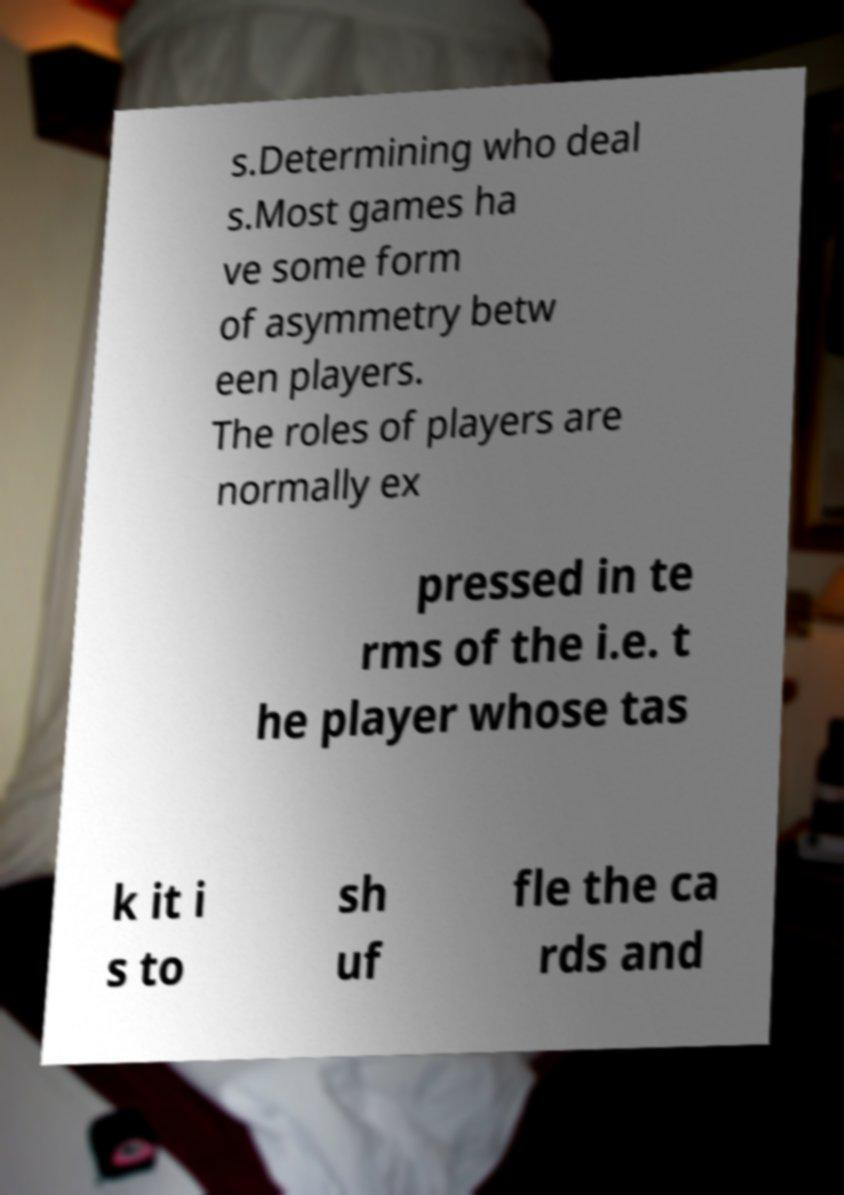Can you read and provide the text displayed in the image?This photo seems to have some interesting text. Can you extract and type it out for me? s.Determining who deal s.Most games ha ve some form of asymmetry betw een players. The roles of players are normally ex pressed in te rms of the i.e. t he player whose tas k it i s to sh uf fle the ca rds and 